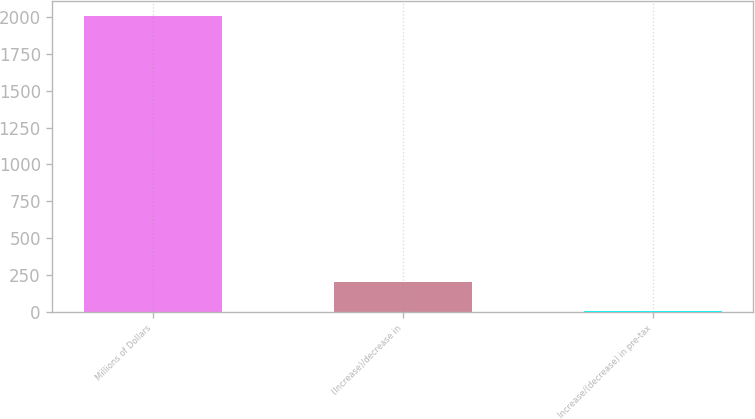Convert chart. <chart><loc_0><loc_0><loc_500><loc_500><bar_chart><fcel>Millions of Dollars<fcel>(Increase)/decrease in<fcel>Increase/(decrease) in pre-tax<nl><fcel>2006<fcel>205.1<fcel>5<nl></chart> 